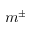<formula> <loc_0><loc_0><loc_500><loc_500>m ^ { \pm }</formula> 